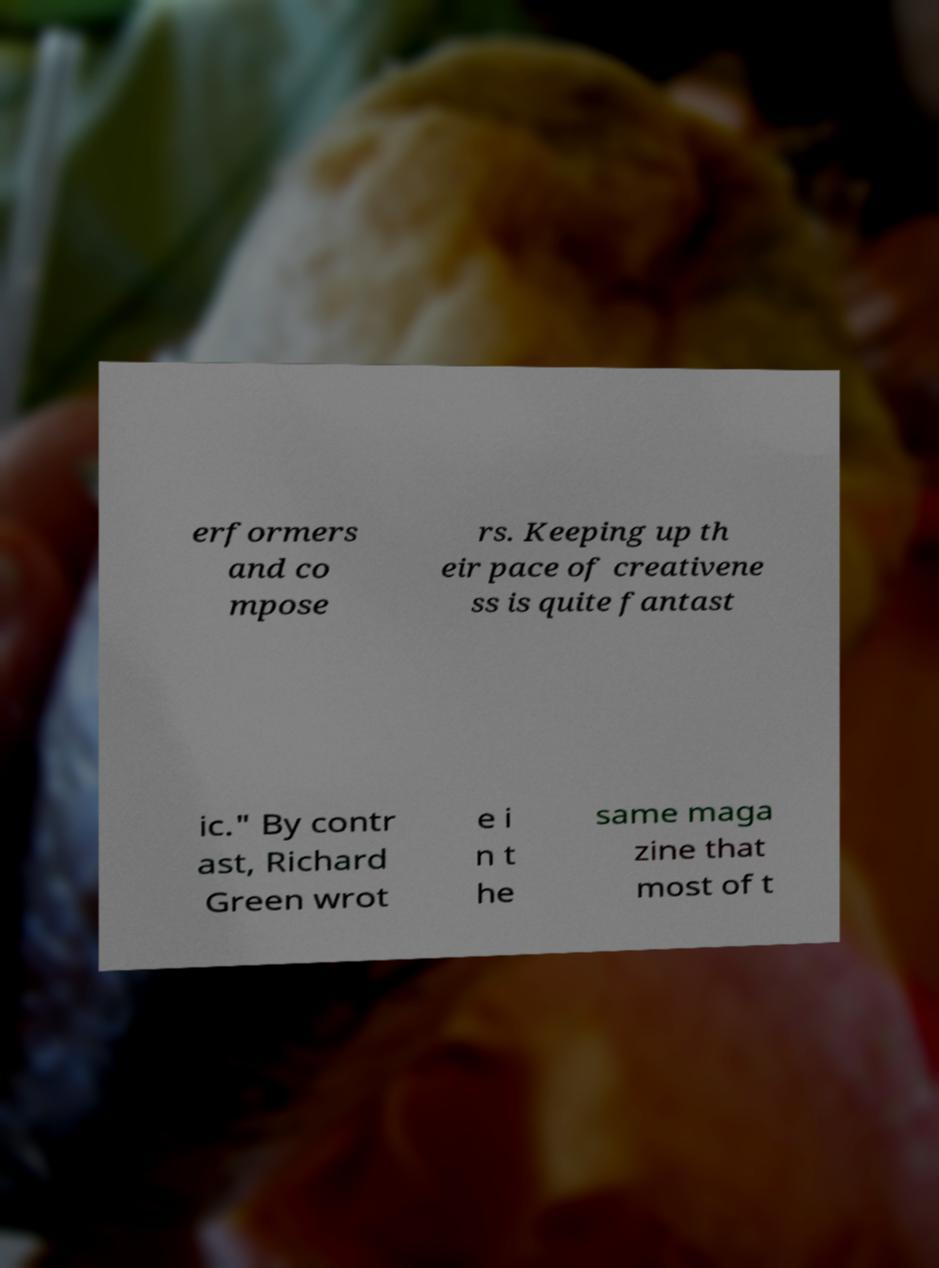Please read and relay the text visible in this image. What does it say? erformers and co mpose rs. Keeping up th eir pace of creativene ss is quite fantast ic." By contr ast, Richard Green wrot e i n t he same maga zine that most of t 